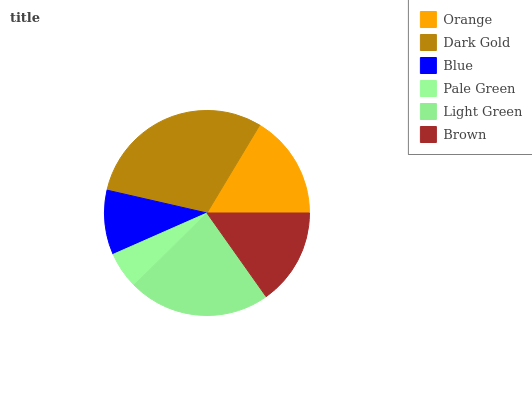Is Pale Green the minimum?
Answer yes or no. Yes. Is Dark Gold the maximum?
Answer yes or no. Yes. Is Blue the minimum?
Answer yes or no. No. Is Blue the maximum?
Answer yes or no. No. Is Dark Gold greater than Blue?
Answer yes or no. Yes. Is Blue less than Dark Gold?
Answer yes or no. Yes. Is Blue greater than Dark Gold?
Answer yes or no. No. Is Dark Gold less than Blue?
Answer yes or no. No. Is Orange the high median?
Answer yes or no. Yes. Is Brown the low median?
Answer yes or no. Yes. Is Dark Gold the high median?
Answer yes or no. No. Is Light Green the low median?
Answer yes or no. No. 